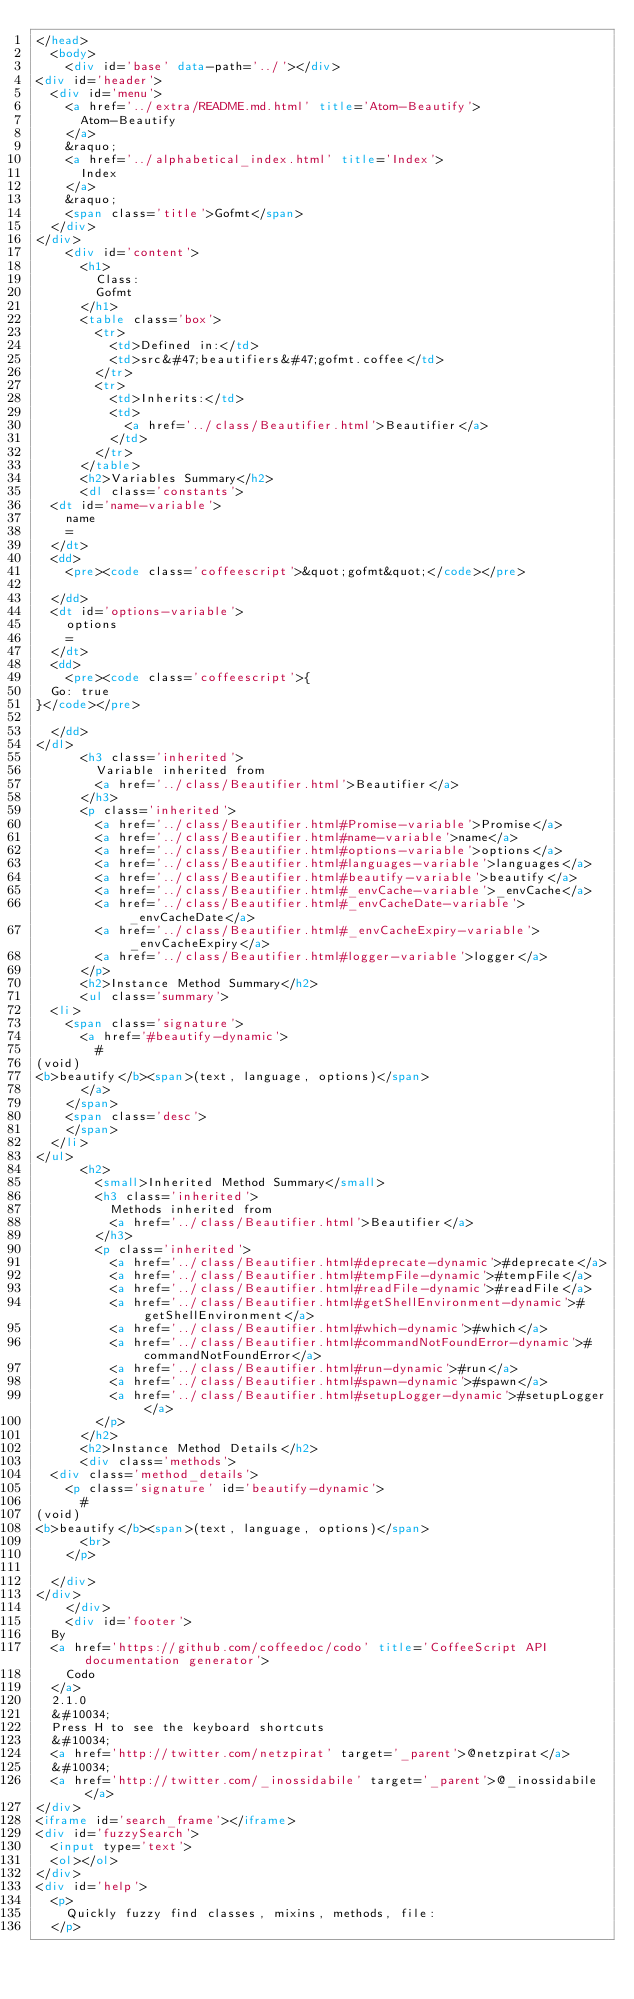<code> <loc_0><loc_0><loc_500><loc_500><_HTML_></head>
  <body>
    <div id='base' data-path='../'></div>
<div id='header'>
  <div id='menu'>
    <a href='../extra/README.md.html' title='Atom-Beautify'>
      Atom-Beautify
    </a>
    &raquo;
    <a href='../alphabetical_index.html' title='Index'>
      Index
    </a>
    &raquo;
    <span class='title'>Gofmt</span>
  </div>
</div>
    <div id='content'>
      <h1>
        Class:
        Gofmt
      </h1>
      <table class='box'>
        <tr>
          <td>Defined in:</td>
          <td>src&#47;beautifiers&#47;gofmt.coffee</td>
        </tr>
        <tr>
          <td>Inherits:</td>
          <td>
            <a href='../class/Beautifier.html'>Beautifier</a>
          </td>
        </tr>
      </table>
      <h2>Variables Summary</h2>
      <dl class='constants'>
  <dt id='name-variable'>
    name
    =
  </dt>
  <dd>
    <pre><code class='coffeescript'>&quot;gofmt&quot;</code></pre>
    
  </dd>
  <dt id='options-variable'>
    options
    =
  </dt>
  <dd>
    <pre><code class='coffeescript'>{
  Go: true
}</code></pre>
    
  </dd>
</dl>
      <h3 class='inherited'>
        Variable inherited from
        <a href='../class/Beautifier.html'>Beautifier</a>
      </h3>
      <p class='inherited'>
        <a href='../class/Beautifier.html#Promise-variable'>Promise</a>
        <a href='../class/Beautifier.html#name-variable'>name</a>
        <a href='../class/Beautifier.html#options-variable'>options</a>
        <a href='../class/Beautifier.html#languages-variable'>languages</a>
        <a href='../class/Beautifier.html#beautify-variable'>beautify</a>
        <a href='../class/Beautifier.html#_envCache-variable'>_envCache</a>
        <a href='../class/Beautifier.html#_envCacheDate-variable'>_envCacheDate</a>
        <a href='../class/Beautifier.html#_envCacheExpiry-variable'>_envCacheExpiry</a>
        <a href='../class/Beautifier.html#logger-variable'>logger</a>
      </p>
      <h2>Instance Method Summary</h2>
      <ul class='summary'>
  <li>
    <span class='signature'>
      <a href='#beautify-dynamic'>
        #
(void)
<b>beautify</b><span>(text, language, options)</span>
      </a>
    </span>
    <span class='desc'>
    </span>
  </li>
</ul>
      <h2>
        <small>Inherited Method Summary</small>
        <h3 class='inherited'>
          Methods inherited from
          <a href='../class/Beautifier.html'>Beautifier</a>
        </h3>
        <p class='inherited'>
          <a href='../class/Beautifier.html#deprecate-dynamic'>#deprecate</a>
          <a href='../class/Beautifier.html#tempFile-dynamic'>#tempFile</a>
          <a href='../class/Beautifier.html#readFile-dynamic'>#readFile</a>
          <a href='../class/Beautifier.html#getShellEnvironment-dynamic'>#getShellEnvironment</a>
          <a href='../class/Beautifier.html#which-dynamic'>#which</a>
          <a href='../class/Beautifier.html#commandNotFoundError-dynamic'>#commandNotFoundError</a>
          <a href='../class/Beautifier.html#run-dynamic'>#run</a>
          <a href='../class/Beautifier.html#spawn-dynamic'>#spawn</a>
          <a href='../class/Beautifier.html#setupLogger-dynamic'>#setupLogger</a>
        </p>
      </h2>
      <h2>Instance Method Details</h2>
      <div class='methods'>
  <div class='method_details'>
    <p class='signature' id='beautify-dynamic'>
      #
(void)
<b>beautify</b><span>(text, language, options)</span>
      <br>
    </p>
    
  </div>
</div>
    </div>
    <div id='footer'>
  By
  <a href='https://github.com/coffeedoc/codo' title='CoffeeScript API documentation generator'>
    Codo
  </a>
  2.1.0
  &#10034;
  Press H to see the keyboard shortcuts
  &#10034;
  <a href='http://twitter.com/netzpirat' target='_parent'>@netzpirat</a>
  &#10034;
  <a href='http://twitter.com/_inossidabile' target='_parent'>@_inossidabile</a>
</div>
<iframe id='search_frame'></iframe>
<div id='fuzzySearch'>
  <input type='text'>
  <ol></ol>
</div>
<div id='help'>
  <p>
    Quickly fuzzy find classes, mixins, methods, file:
  </p></code> 